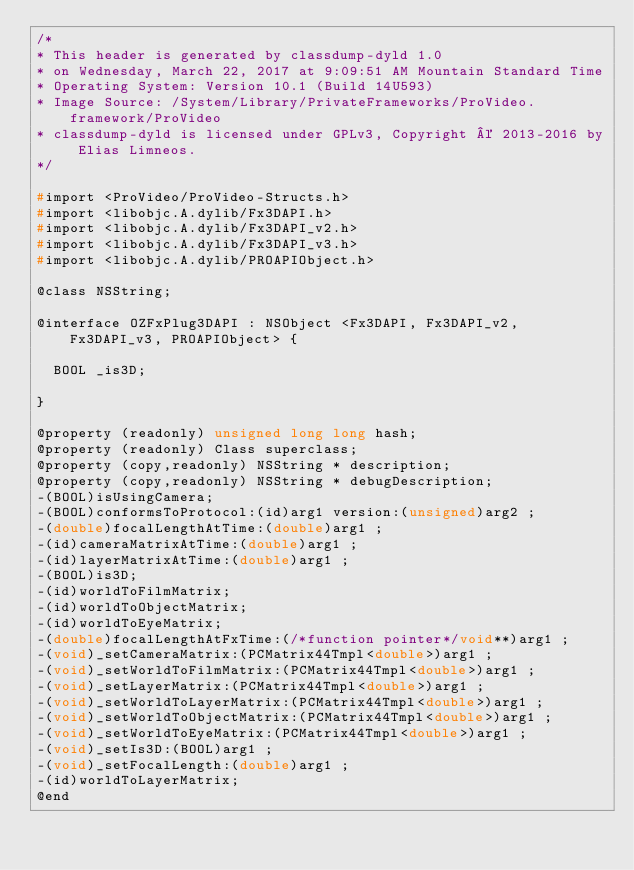Convert code to text. <code><loc_0><loc_0><loc_500><loc_500><_C_>/*
* This header is generated by classdump-dyld 1.0
* on Wednesday, March 22, 2017 at 9:09:51 AM Mountain Standard Time
* Operating System: Version 10.1 (Build 14U593)
* Image Source: /System/Library/PrivateFrameworks/ProVideo.framework/ProVideo
* classdump-dyld is licensed under GPLv3, Copyright © 2013-2016 by Elias Limneos.
*/

#import <ProVideo/ProVideo-Structs.h>
#import <libobjc.A.dylib/Fx3DAPI.h>
#import <libobjc.A.dylib/Fx3DAPI_v2.h>
#import <libobjc.A.dylib/Fx3DAPI_v3.h>
#import <libobjc.A.dylib/PROAPIObject.h>

@class NSString;

@interface OZFxPlug3DAPI : NSObject <Fx3DAPI, Fx3DAPI_v2, Fx3DAPI_v3, PROAPIObject> {

	BOOL _is3D;

}

@property (readonly) unsigned long long hash; 
@property (readonly) Class superclass; 
@property (copy,readonly) NSString * description; 
@property (copy,readonly) NSString * debugDescription; 
-(BOOL)isUsingCamera;
-(BOOL)conformsToProtocol:(id)arg1 version:(unsigned)arg2 ;
-(double)focalLengthAtTime:(double)arg1 ;
-(id)cameraMatrixAtTime:(double)arg1 ;
-(id)layerMatrixAtTime:(double)arg1 ;
-(BOOL)is3D;
-(id)worldToFilmMatrix;
-(id)worldToObjectMatrix;
-(id)worldToEyeMatrix;
-(double)focalLengthAtFxTime:(/*function pointer*/void**)arg1 ;
-(void)_setCameraMatrix:(PCMatrix44Tmpl<double>)arg1 ;
-(void)_setWorldToFilmMatrix:(PCMatrix44Tmpl<double>)arg1 ;
-(void)_setLayerMatrix:(PCMatrix44Tmpl<double>)arg1 ;
-(void)_setWorldToLayerMatrix:(PCMatrix44Tmpl<double>)arg1 ;
-(void)_setWorldToObjectMatrix:(PCMatrix44Tmpl<double>)arg1 ;
-(void)_setWorldToEyeMatrix:(PCMatrix44Tmpl<double>)arg1 ;
-(void)_setIs3D:(BOOL)arg1 ;
-(void)_setFocalLength:(double)arg1 ;
-(id)worldToLayerMatrix;
@end

</code> 